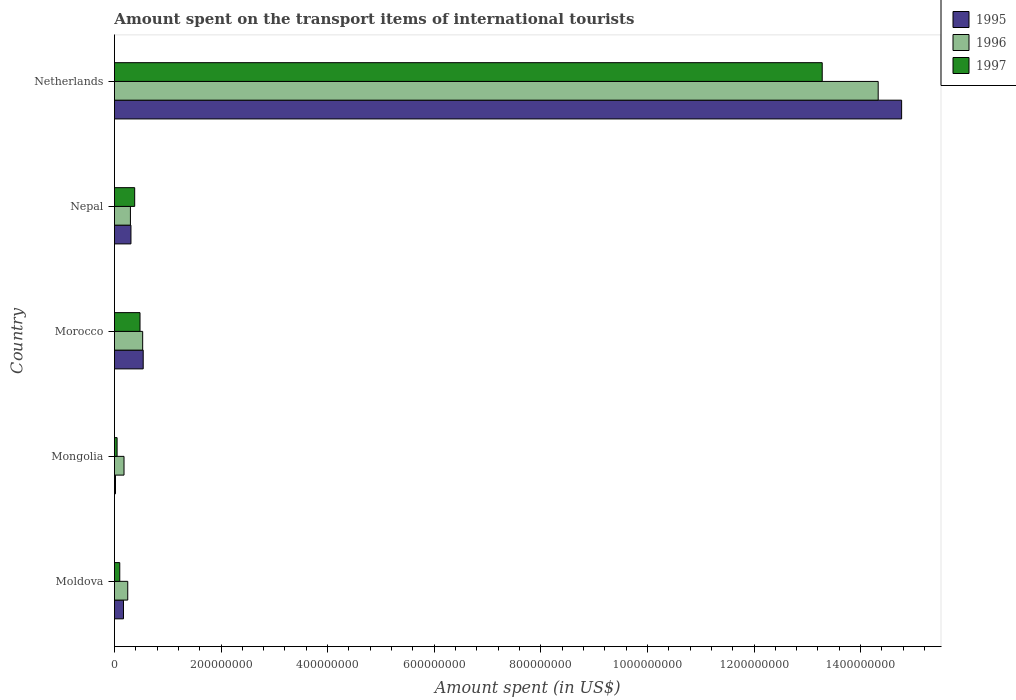How many bars are there on the 4th tick from the bottom?
Provide a short and direct response. 3. What is the label of the 3rd group of bars from the top?
Ensure brevity in your answer.  Morocco. In how many cases, is the number of bars for a given country not equal to the number of legend labels?
Make the answer very short. 0. What is the amount spent on the transport items of international tourists in 1995 in Nepal?
Your response must be concise. 3.10e+07. Across all countries, what is the maximum amount spent on the transport items of international tourists in 1995?
Make the answer very short. 1.48e+09. Across all countries, what is the minimum amount spent on the transport items of international tourists in 1995?
Make the answer very short. 2.00e+06. In which country was the amount spent on the transport items of international tourists in 1995 minimum?
Provide a succinct answer. Mongolia. What is the total amount spent on the transport items of international tourists in 1995 in the graph?
Provide a succinct answer. 1.58e+09. What is the difference between the amount spent on the transport items of international tourists in 1995 in Mongolia and that in Nepal?
Give a very brief answer. -2.90e+07. What is the difference between the amount spent on the transport items of international tourists in 1995 in Moldova and the amount spent on the transport items of international tourists in 1996 in Morocco?
Your answer should be compact. -3.60e+07. What is the average amount spent on the transport items of international tourists in 1997 per country?
Give a very brief answer. 2.86e+08. What is the difference between the amount spent on the transport items of international tourists in 1996 and amount spent on the transport items of international tourists in 1995 in Moldova?
Your response must be concise. 8.00e+06. In how many countries, is the amount spent on the transport items of international tourists in 1997 greater than 360000000 US$?
Offer a very short reply. 1. What is the ratio of the amount spent on the transport items of international tourists in 1995 in Nepal to that in Netherlands?
Provide a succinct answer. 0.02. What is the difference between the highest and the second highest amount spent on the transport items of international tourists in 1997?
Provide a short and direct response. 1.28e+09. What is the difference between the highest and the lowest amount spent on the transport items of international tourists in 1996?
Offer a terse response. 1.42e+09. In how many countries, is the amount spent on the transport items of international tourists in 1995 greater than the average amount spent on the transport items of international tourists in 1995 taken over all countries?
Ensure brevity in your answer.  1. Is it the case that in every country, the sum of the amount spent on the transport items of international tourists in 1996 and amount spent on the transport items of international tourists in 1995 is greater than the amount spent on the transport items of international tourists in 1997?
Your answer should be very brief. Yes. How many bars are there?
Provide a short and direct response. 15. Are all the bars in the graph horizontal?
Provide a short and direct response. Yes. How many countries are there in the graph?
Ensure brevity in your answer.  5. Does the graph contain any zero values?
Provide a short and direct response. No. How many legend labels are there?
Offer a terse response. 3. How are the legend labels stacked?
Your answer should be compact. Vertical. What is the title of the graph?
Ensure brevity in your answer.  Amount spent on the transport items of international tourists. Does "1962" appear as one of the legend labels in the graph?
Your answer should be compact. No. What is the label or title of the X-axis?
Ensure brevity in your answer.  Amount spent (in US$). What is the label or title of the Y-axis?
Your response must be concise. Country. What is the Amount spent (in US$) in 1995 in Moldova?
Offer a very short reply. 1.70e+07. What is the Amount spent (in US$) of 1996 in Moldova?
Offer a very short reply. 2.50e+07. What is the Amount spent (in US$) of 1996 in Mongolia?
Ensure brevity in your answer.  1.80e+07. What is the Amount spent (in US$) of 1997 in Mongolia?
Your response must be concise. 5.00e+06. What is the Amount spent (in US$) in 1995 in Morocco?
Your answer should be very brief. 5.40e+07. What is the Amount spent (in US$) in 1996 in Morocco?
Your response must be concise. 5.30e+07. What is the Amount spent (in US$) of 1997 in Morocco?
Make the answer very short. 4.80e+07. What is the Amount spent (in US$) of 1995 in Nepal?
Ensure brevity in your answer.  3.10e+07. What is the Amount spent (in US$) of 1996 in Nepal?
Make the answer very short. 3.00e+07. What is the Amount spent (in US$) in 1997 in Nepal?
Give a very brief answer. 3.80e+07. What is the Amount spent (in US$) of 1995 in Netherlands?
Your answer should be very brief. 1.48e+09. What is the Amount spent (in US$) of 1996 in Netherlands?
Your answer should be compact. 1.43e+09. What is the Amount spent (in US$) of 1997 in Netherlands?
Give a very brief answer. 1.33e+09. Across all countries, what is the maximum Amount spent (in US$) of 1995?
Provide a succinct answer. 1.48e+09. Across all countries, what is the maximum Amount spent (in US$) in 1996?
Offer a very short reply. 1.43e+09. Across all countries, what is the maximum Amount spent (in US$) in 1997?
Your response must be concise. 1.33e+09. Across all countries, what is the minimum Amount spent (in US$) of 1995?
Give a very brief answer. 2.00e+06. Across all countries, what is the minimum Amount spent (in US$) in 1996?
Make the answer very short. 1.80e+07. Across all countries, what is the minimum Amount spent (in US$) of 1997?
Make the answer very short. 5.00e+06. What is the total Amount spent (in US$) of 1995 in the graph?
Your answer should be very brief. 1.58e+09. What is the total Amount spent (in US$) in 1996 in the graph?
Keep it short and to the point. 1.56e+09. What is the total Amount spent (in US$) of 1997 in the graph?
Make the answer very short. 1.43e+09. What is the difference between the Amount spent (in US$) of 1995 in Moldova and that in Mongolia?
Provide a short and direct response. 1.50e+07. What is the difference between the Amount spent (in US$) in 1997 in Moldova and that in Mongolia?
Keep it short and to the point. 5.00e+06. What is the difference between the Amount spent (in US$) of 1995 in Moldova and that in Morocco?
Provide a short and direct response. -3.70e+07. What is the difference between the Amount spent (in US$) of 1996 in Moldova and that in Morocco?
Give a very brief answer. -2.80e+07. What is the difference between the Amount spent (in US$) in 1997 in Moldova and that in Morocco?
Offer a terse response. -3.80e+07. What is the difference between the Amount spent (in US$) in 1995 in Moldova and that in Nepal?
Your answer should be very brief. -1.40e+07. What is the difference between the Amount spent (in US$) in 1996 in Moldova and that in Nepal?
Provide a short and direct response. -5.00e+06. What is the difference between the Amount spent (in US$) of 1997 in Moldova and that in Nepal?
Ensure brevity in your answer.  -2.80e+07. What is the difference between the Amount spent (in US$) in 1995 in Moldova and that in Netherlands?
Offer a very short reply. -1.46e+09. What is the difference between the Amount spent (in US$) in 1996 in Moldova and that in Netherlands?
Offer a very short reply. -1.41e+09. What is the difference between the Amount spent (in US$) in 1997 in Moldova and that in Netherlands?
Make the answer very short. -1.32e+09. What is the difference between the Amount spent (in US$) of 1995 in Mongolia and that in Morocco?
Offer a terse response. -5.20e+07. What is the difference between the Amount spent (in US$) in 1996 in Mongolia and that in Morocco?
Give a very brief answer. -3.50e+07. What is the difference between the Amount spent (in US$) of 1997 in Mongolia and that in Morocco?
Provide a short and direct response. -4.30e+07. What is the difference between the Amount spent (in US$) of 1995 in Mongolia and that in Nepal?
Give a very brief answer. -2.90e+07. What is the difference between the Amount spent (in US$) in 1996 in Mongolia and that in Nepal?
Keep it short and to the point. -1.20e+07. What is the difference between the Amount spent (in US$) of 1997 in Mongolia and that in Nepal?
Give a very brief answer. -3.30e+07. What is the difference between the Amount spent (in US$) of 1995 in Mongolia and that in Netherlands?
Ensure brevity in your answer.  -1.48e+09. What is the difference between the Amount spent (in US$) in 1996 in Mongolia and that in Netherlands?
Make the answer very short. -1.42e+09. What is the difference between the Amount spent (in US$) in 1997 in Mongolia and that in Netherlands?
Make the answer very short. -1.32e+09. What is the difference between the Amount spent (in US$) in 1995 in Morocco and that in Nepal?
Your answer should be very brief. 2.30e+07. What is the difference between the Amount spent (in US$) in 1996 in Morocco and that in Nepal?
Keep it short and to the point. 2.30e+07. What is the difference between the Amount spent (in US$) of 1997 in Morocco and that in Nepal?
Keep it short and to the point. 1.00e+07. What is the difference between the Amount spent (in US$) of 1995 in Morocco and that in Netherlands?
Provide a succinct answer. -1.42e+09. What is the difference between the Amount spent (in US$) in 1996 in Morocco and that in Netherlands?
Provide a succinct answer. -1.38e+09. What is the difference between the Amount spent (in US$) in 1997 in Morocco and that in Netherlands?
Offer a very short reply. -1.28e+09. What is the difference between the Amount spent (in US$) of 1995 in Nepal and that in Netherlands?
Offer a terse response. -1.45e+09. What is the difference between the Amount spent (in US$) of 1996 in Nepal and that in Netherlands?
Ensure brevity in your answer.  -1.40e+09. What is the difference between the Amount spent (in US$) of 1997 in Nepal and that in Netherlands?
Make the answer very short. -1.29e+09. What is the difference between the Amount spent (in US$) in 1995 in Moldova and the Amount spent (in US$) in 1996 in Morocco?
Provide a succinct answer. -3.60e+07. What is the difference between the Amount spent (in US$) of 1995 in Moldova and the Amount spent (in US$) of 1997 in Morocco?
Your answer should be very brief. -3.10e+07. What is the difference between the Amount spent (in US$) of 1996 in Moldova and the Amount spent (in US$) of 1997 in Morocco?
Give a very brief answer. -2.30e+07. What is the difference between the Amount spent (in US$) in 1995 in Moldova and the Amount spent (in US$) in 1996 in Nepal?
Keep it short and to the point. -1.30e+07. What is the difference between the Amount spent (in US$) in 1995 in Moldova and the Amount spent (in US$) in 1997 in Nepal?
Give a very brief answer. -2.10e+07. What is the difference between the Amount spent (in US$) in 1996 in Moldova and the Amount spent (in US$) in 1997 in Nepal?
Make the answer very short. -1.30e+07. What is the difference between the Amount spent (in US$) of 1995 in Moldova and the Amount spent (in US$) of 1996 in Netherlands?
Your answer should be very brief. -1.42e+09. What is the difference between the Amount spent (in US$) in 1995 in Moldova and the Amount spent (in US$) in 1997 in Netherlands?
Your answer should be very brief. -1.31e+09. What is the difference between the Amount spent (in US$) in 1996 in Moldova and the Amount spent (in US$) in 1997 in Netherlands?
Your answer should be compact. -1.30e+09. What is the difference between the Amount spent (in US$) of 1995 in Mongolia and the Amount spent (in US$) of 1996 in Morocco?
Offer a very short reply. -5.10e+07. What is the difference between the Amount spent (in US$) in 1995 in Mongolia and the Amount spent (in US$) in 1997 in Morocco?
Keep it short and to the point. -4.60e+07. What is the difference between the Amount spent (in US$) of 1996 in Mongolia and the Amount spent (in US$) of 1997 in Morocco?
Your response must be concise. -3.00e+07. What is the difference between the Amount spent (in US$) in 1995 in Mongolia and the Amount spent (in US$) in 1996 in Nepal?
Give a very brief answer. -2.80e+07. What is the difference between the Amount spent (in US$) of 1995 in Mongolia and the Amount spent (in US$) of 1997 in Nepal?
Your answer should be very brief. -3.60e+07. What is the difference between the Amount spent (in US$) in 1996 in Mongolia and the Amount spent (in US$) in 1997 in Nepal?
Provide a short and direct response. -2.00e+07. What is the difference between the Amount spent (in US$) of 1995 in Mongolia and the Amount spent (in US$) of 1996 in Netherlands?
Keep it short and to the point. -1.43e+09. What is the difference between the Amount spent (in US$) of 1995 in Mongolia and the Amount spent (in US$) of 1997 in Netherlands?
Give a very brief answer. -1.33e+09. What is the difference between the Amount spent (in US$) in 1996 in Mongolia and the Amount spent (in US$) in 1997 in Netherlands?
Offer a terse response. -1.31e+09. What is the difference between the Amount spent (in US$) of 1995 in Morocco and the Amount spent (in US$) of 1996 in Nepal?
Your answer should be compact. 2.40e+07. What is the difference between the Amount spent (in US$) of 1995 in Morocco and the Amount spent (in US$) of 1997 in Nepal?
Your response must be concise. 1.60e+07. What is the difference between the Amount spent (in US$) in 1996 in Morocco and the Amount spent (in US$) in 1997 in Nepal?
Your answer should be very brief. 1.50e+07. What is the difference between the Amount spent (in US$) of 1995 in Morocco and the Amount spent (in US$) of 1996 in Netherlands?
Give a very brief answer. -1.38e+09. What is the difference between the Amount spent (in US$) of 1995 in Morocco and the Amount spent (in US$) of 1997 in Netherlands?
Keep it short and to the point. -1.27e+09. What is the difference between the Amount spent (in US$) in 1996 in Morocco and the Amount spent (in US$) in 1997 in Netherlands?
Ensure brevity in your answer.  -1.28e+09. What is the difference between the Amount spent (in US$) in 1995 in Nepal and the Amount spent (in US$) in 1996 in Netherlands?
Offer a terse response. -1.40e+09. What is the difference between the Amount spent (in US$) in 1995 in Nepal and the Amount spent (in US$) in 1997 in Netherlands?
Make the answer very short. -1.30e+09. What is the difference between the Amount spent (in US$) of 1996 in Nepal and the Amount spent (in US$) of 1997 in Netherlands?
Ensure brevity in your answer.  -1.30e+09. What is the average Amount spent (in US$) of 1995 per country?
Provide a succinct answer. 3.16e+08. What is the average Amount spent (in US$) of 1996 per country?
Keep it short and to the point. 3.12e+08. What is the average Amount spent (in US$) in 1997 per country?
Offer a terse response. 2.86e+08. What is the difference between the Amount spent (in US$) of 1995 and Amount spent (in US$) of 1996 in Moldova?
Offer a terse response. -8.00e+06. What is the difference between the Amount spent (in US$) in 1995 and Amount spent (in US$) in 1997 in Moldova?
Your response must be concise. 7.00e+06. What is the difference between the Amount spent (in US$) in 1996 and Amount spent (in US$) in 1997 in Moldova?
Offer a very short reply. 1.50e+07. What is the difference between the Amount spent (in US$) in 1995 and Amount spent (in US$) in 1996 in Mongolia?
Your answer should be compact. -1.60e+07. What is the difference between the Amount spent (in US$) in 1996 and Amount spent (in US$) in 1997 in Mongolia?
Your response must be concise. 1.30e+07. What is the difference between the Amount spent (in US$) of 1995 and Amount spent (in US$) of 1997 in Morocco?
Your answer should be very brief. 6.00e+06. What is the difference between the Amount spent (in US$) of 1995 and Amount spent (in US$) of 1996 in Nepal?
Offer a terse response. 1.00e+06. What is the difference between the Amount spent (in US$) in 1995 and Amount spent (in US$) in 1997 in Nepal?
Ensure brevity in your answer.  -7.00e+06. What is the difference between the Amount spent (in US$) of 1996 and Amount spent (in US$) of 1997 in Nepal?
Give a very brief answer. -8.00e+06. What is the difference between the Amount spent (in US$) in 1995 and Amount spent (in US$) in 1996 in Netherlands?
Ensure brevity in your answer.  4.40e+07. What is the difference between the Amount spent (in US$) in 1995 and Amount spent (in US$) in 1997 in Netherlands?
Your answer should be compact. 1.49e+08. What is the difference between the Amount spent (in US$) of 1996 and Amount spent (in US$) of 1997 in Netherlands?
Ensure brevity in your answer.  1.05e+08. What is the ratio of the Amount spent (in US$) in 1995 in Moldova to that in Mongolia?
Ensure brevity in your answer.  8.5. What is the ratio of the Amount spent (in US$) of 1996 in Moldova to that in Mongolia?
Offer a terse response. 1.39. What is the ratio of the Amount spent (in US$) in 1995 in Moldova to that in Morocco?
Your response must be concise. 0.31. What is the ratio of the Amount spent (in US$) in 1996 in Moldova to that in Morocco?
Offer a terse response. 0.47. What is the ratio of the Amount spent (in US$) in 1997 in Moldova to that in Morocco?
Provide a short and direct response. 0.21. What is the ratio of the Amount spent (in US$) in 1995 in Moldova to that in Nepal?
Make the answer very short. 0.55. What is the ratio of the Amount spent (in US$) in 1997 in Moldova to that in Nepal?
Provide a short and direct response. 0.26. What is the ratio of the Amount spent (in US$) in 1995 in Moldova to that in Netherlands?
Your answer should be compact. 0.01. What is the ratio of the Amount spent (in US$) in 1996 in Moldova to that in Netherlands?
Provide a short and direct response. 0.02. What is the ratio of the Amount spent (in US$) of 1997 in Moldova to that in Netherlands?
Offer a very short reply. 0.01. What is the ratio of the Amount spent (in US$) in 1995 in Mongolia to that in Morocco?
Keep it short and to the point. 0.04. What is the ratio of the Amount spent (in US$) in 1996 in Mongolia to that in Morocco?
Your response must be concise. 0.34. What is the ratio of the Amount spent (in US$) of 1997 in Mongolia to that in Morocco?
Give a very brief answer. 0.1. What is the ratio of the Amount spent (in US$) in 1995 in Mongolia to that in Nepal?
Give a very brief answer. 0.06. What is the ratio of the Amount spent (in US$) in 1996 in Mongolia to that in Nepal?
Ensure brevity in your answer.  0.6. What is the ratio of the Amount spent (in US$) of 1997 in Mongolia to that in Nepal?
Keep it short and to the point. 0.13. What is the ratio of the Amount spent (in US$) in 1995 in Mongolia to that in Netherlands?
Keep it short and to the point. 0. What is the ratio of the Amount spent (in US$) of 1996 in Mongolia to that in Netherlands?
Keep it short and to the point. 0.01. What is the ratio of the Amount spent (in US$) of 1997 in Mongolia to that in Netherlands?
Your response must be concise. 0. What is the ratio of the Amount spent (in US$) of 1995 in Morocco to that in Nepal?
Provide a succinct answer. 1.74. What is the ratio of the Amount spent (in US$) in 1996 in Morocco to that in Nepal?
Offer a terse response. 1.77. What is the ratio of the Amount spent (in US$) in 1997 in Morocco to that in Nepal?
Offer a terse response. 1.26. What is the ratio of the Amount spent (in US$) in 1995 in Morocco to that in Netherlands?
Give a very brief answer. 0.04. What is the ratio of the Amount spent (in US$) in 1996 in Morocco to that in Netherlands?
Keep it short and to the point. 0.04. What is the ratio of the Amount spent (in US$) of 1997 in Morocco to that in Netherlands?
Provide a short and direct response. 0.04. What is the ratio of the Amount spent (in US$) in 1995 in Nepal to that in Netherlands?
Provide a short and direct response. 0.02. What is the ratio of the Amount spent (in US$) of 1996 in Nepal to that in Netherlands?
Offer a terse response. 0.02. What is the ratio of the Amount spent (in US$) of 1997 in Nepal to that in Netherlands?
Keep it short and to the point. 0.03. What is the difference between the highest and the second highest Amount spent (in US$) in 1995?
Your answer should be very brief. 1.42e+09. What is the difference between the highest and the second highest Amount spent (in US$) of 1996?
Offer a terse response. 1.38e+09. What is the difference between the highest and the second highest Amount spent (in US$) in 1997?
Offer a terse response. 1.28e+09. What is the difference between the highest and the lowest Amount spent (in US$) in 1995?
Offer a terse response. 1.48e+09. What is the difference between the highest and the lowest Amount spent (in US$) in 1996?
Ensure brevity in your answer.  1.42e+09. What is the difference between the highest and the lowest Amount spent (in US$) in 1997?
Offer a very short reply. 1.32e+09. 